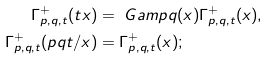<formula> <loc_0><loc_0><loc_500><loc_500>\Gamma ^ { + } _ { p , q , t } ( t x ) & = \ G a m p q ( x ) \Gamma ^ { + } _ { p , q , t } ( x ) , \\ \Gamma ^ { + } _ { p , q , t } ( p q t / x ) & = \Gamma ^ { + } _ { p , q , t } ( x ) ;</formula> 